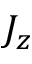Convert formula to latex. <formula><loc_0><loc_0><loc_500><loc_500>J _ { z }</formula> 